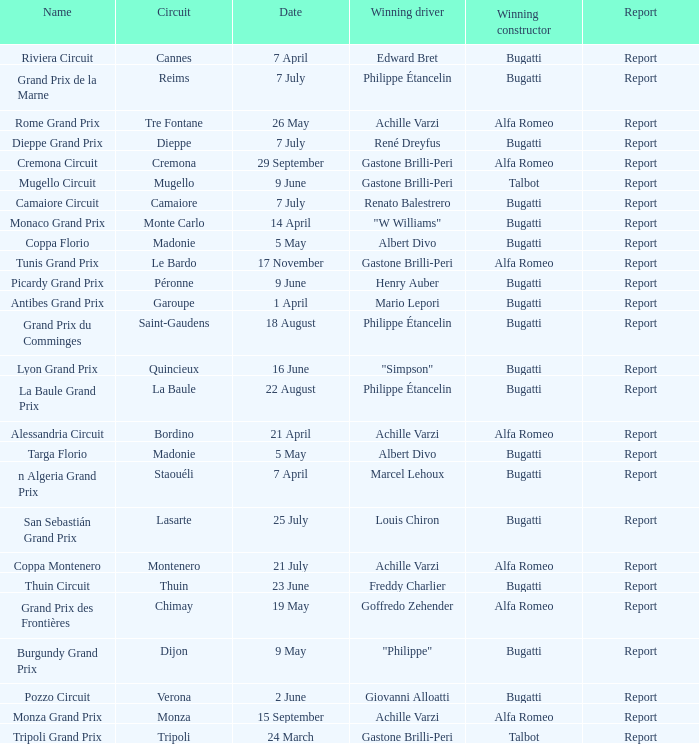What Winning driver has a Name of mugello circuit? Gastone Brilli-Peri. 